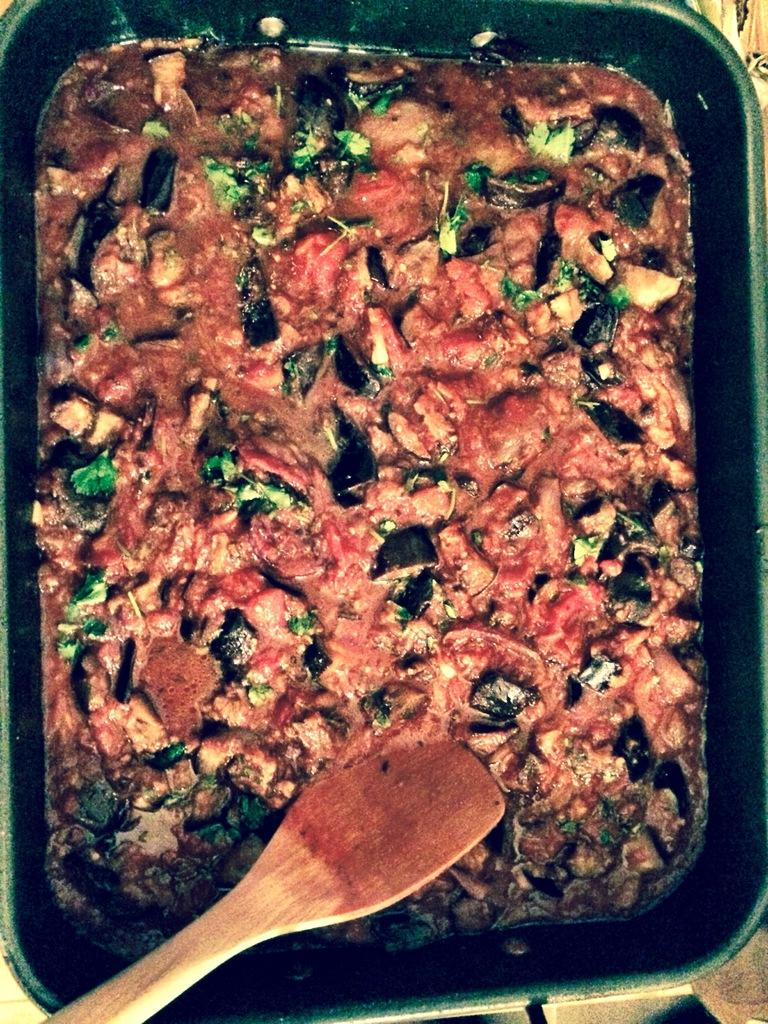What utensil is visible in the image? There is a spoon in the image. What is the spoon used for in the image? The spoon is likely used for eating the food in the bowl. What type of food is in the bowl? The food in the bowl has leaves on it, which suggests it might be a salad or a dish with leafy greens. What type of skirt is being worn by the stranger in the image? There is no stranger present in the image, and therefore no skirt to be worn. 